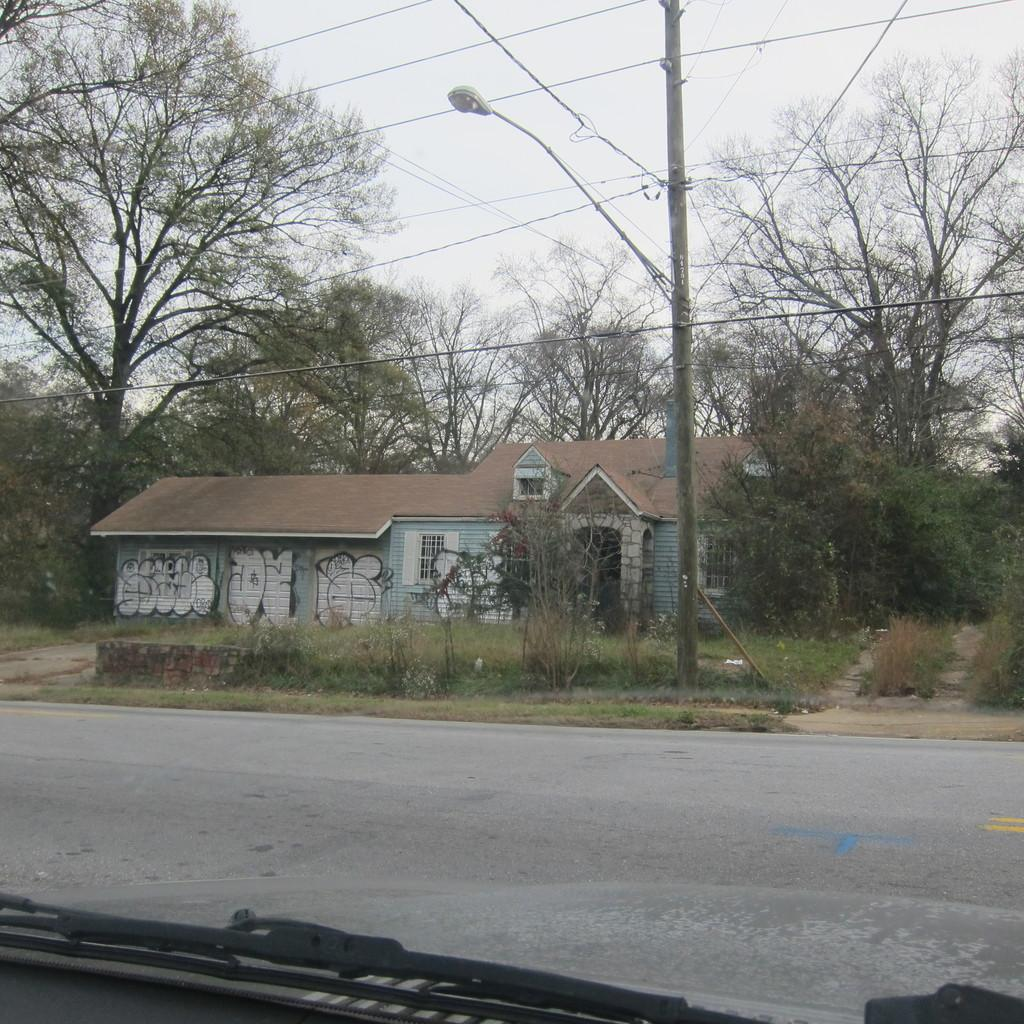What type of structure is present in the image? There is a shed in the image. What other natural elements can be seen in the image? There are trees in the image. What is present at the top of the image? There are wires and the sky visible at the top of the image. What else can be seen in the image? There is a pole in the image. What is located at the bottom of the image? There is a car at the bottom of the image. What type of approval does the governor need to print more trees in the image? There is no governor or printing of trees mentioned in the image; it features a shed, trees, wires, the sky, a pole, and a car. 